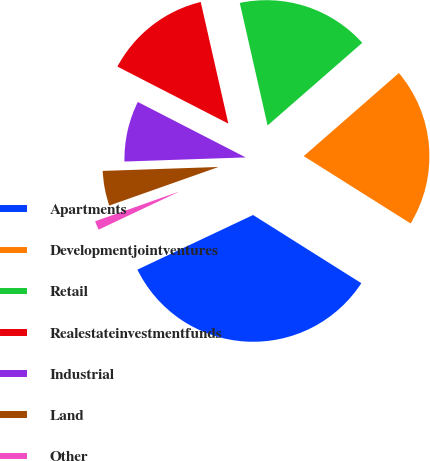Convert chart to OTSL. <chart><loc_0><loc_0><loc_500><loc_500><pie_chart><fcel>Apartments<fcel>Developmentjointventures<fcel>Retail<fcel>Realestateinvestmentfunds<fcel>Industrial<fcel>Land<fcel>Other<nl><fcel>34.03%<fcel>20.37%<fcel>17.13%<fcel>13.89%<fcel>8.1%<fcel>4.86%<fcel>1.62%<nl></chart> 